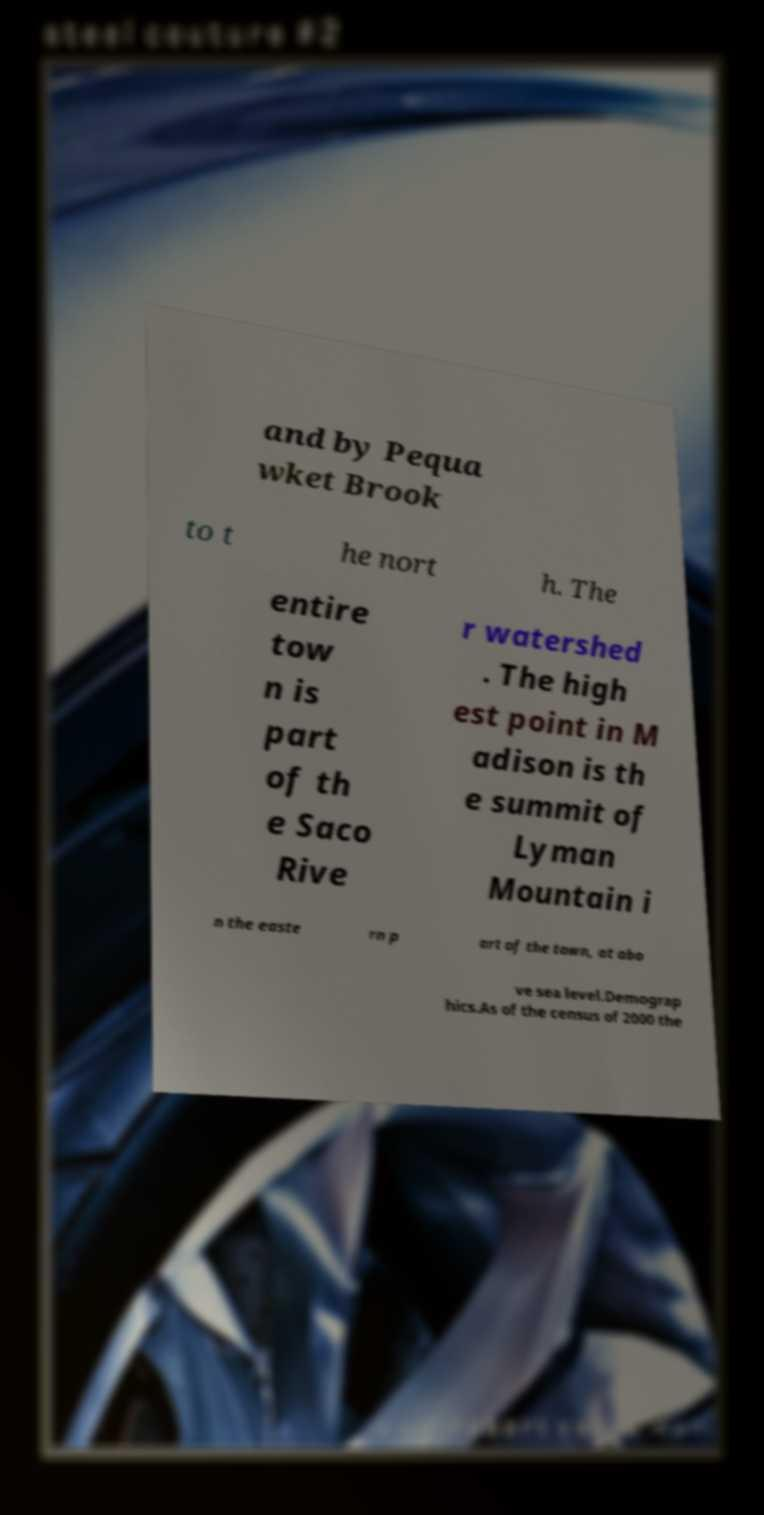Please read and relay the text visible in this image. What does it say? and by Pequa wket Brook to t he nort h. The entire tow n is part of th e Saco Rive r watershed . The high est point in M adison is th e summit of Lyman Mountain i n the easte rn p art of the town, at abo ve sea level.Demograp hics.As of the census of 2000 the 